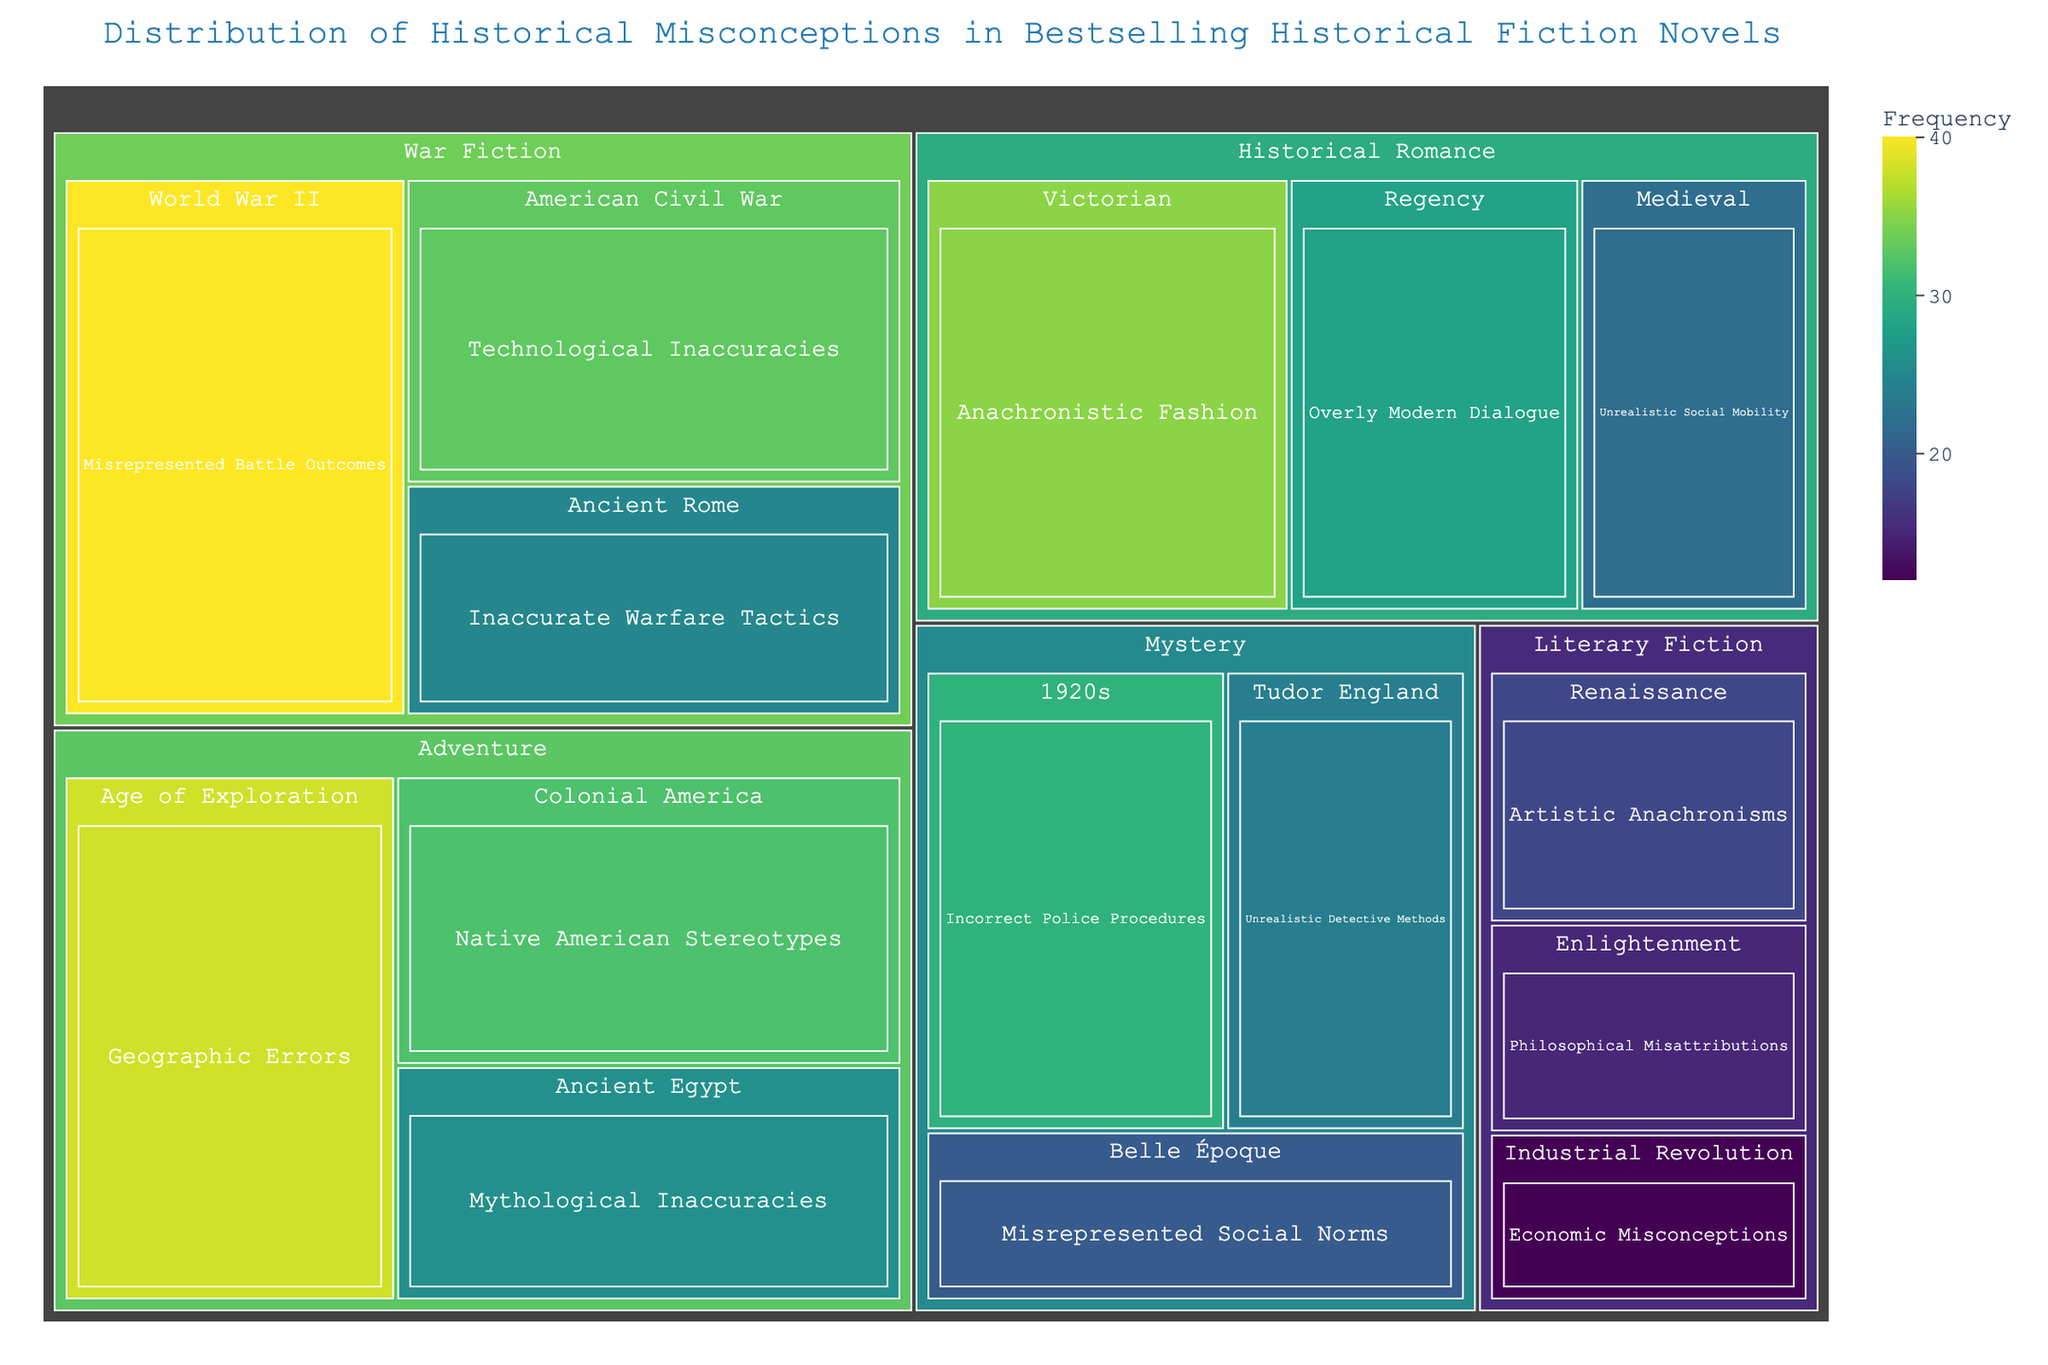What is the title of the treemap? The title is positioned at the top of the treemap and clearly indicates what the chart depicts.
Answer: Distribution of Historical Misconceptions in Bestselling Historical Fiction Novels Which genre and era combination has the highest frequency of historical misconceptions? By examining the size and color intensity of the segments within the treemap, the largest and darkest segment represents the highest frequency.
Answer: War Fiction, World War II How many historical misconceptions are listed for the genre 'Mystery'? To find the total frequency for the Mystery genre, sum the frequency values for each era within this genre. These are 30 (1920s), 24 (Tudor England), and 20 (Belle Époque). So, 30 + 24 + 20 = 74.
Answer: 74 Which misconception is more frequent: 'Geographic Errors' in the 'Age of Exploration' or 'Misrepresented Battle Outcomes' in 'World War II'? Compare the frequency values for both misconceptions. Geographic Errors have a frequency of 38, and Misrepresented Battle Outcomes have a frequency of 40.
Answer: Misrepresented Battle Outcomes What are the three most frequent misconceptions in the entire dataset? Identify the three largest segments in the treemap by both size and color intensity, corresponding to frequencies of 40, 38, and 35. These are Misrepresented Battle Outcomes (40, World War II), Geographic Errors (38, Age of Exploration), and Anachronistic Fashion (35, Victorian).
Answer: Misrepresented Battle Outcomes, Geographic Errors, Anachronistic Fashion What is the average frequency of misconceptions in the 'Historical Romance' genre? Calculate the average by summing the misconception frequencies within the Historical Romance genre (35 for Victorian, 28 for Regency, 22 for Medieval) and dividing by the number of misconceptions (3). So, (35 + 28 + 22) / 3 = 85 / 3 ≈ 28.33.
Answer: 28.33 Which era within the 'Literary Fiction' genre has the fewest misconceptions? Look for the smallest segment within the Literary Fiction section of the treemap, which corresponds to the lowest frequency. The smallest segment is Industrial Revolution with a frequency of 12.
Answer: Industrial Revolution Are there more misconceptions in 'War Fiction' or 'Adventure' genres? Sum the frequencies for each era within both categories. War Fiction: 40 (World War II) + 33 (American Civil War) + 25 (Ancient Rome) = 98. Adventure: 38 (Age of Exploration) + 32 (Colonial America) + 26 (Ancient Egypt) = 96. Compare the totals: War Fiction has 98, Adventure has 96.
Answer: War Fiction Which genre and era combination deals with 'Unrealistic Social Mobility'? Locate the specific misconception within the treemap. It is found under Historical Romance and Medieval.
Answer: Historical Romance, Medieval 